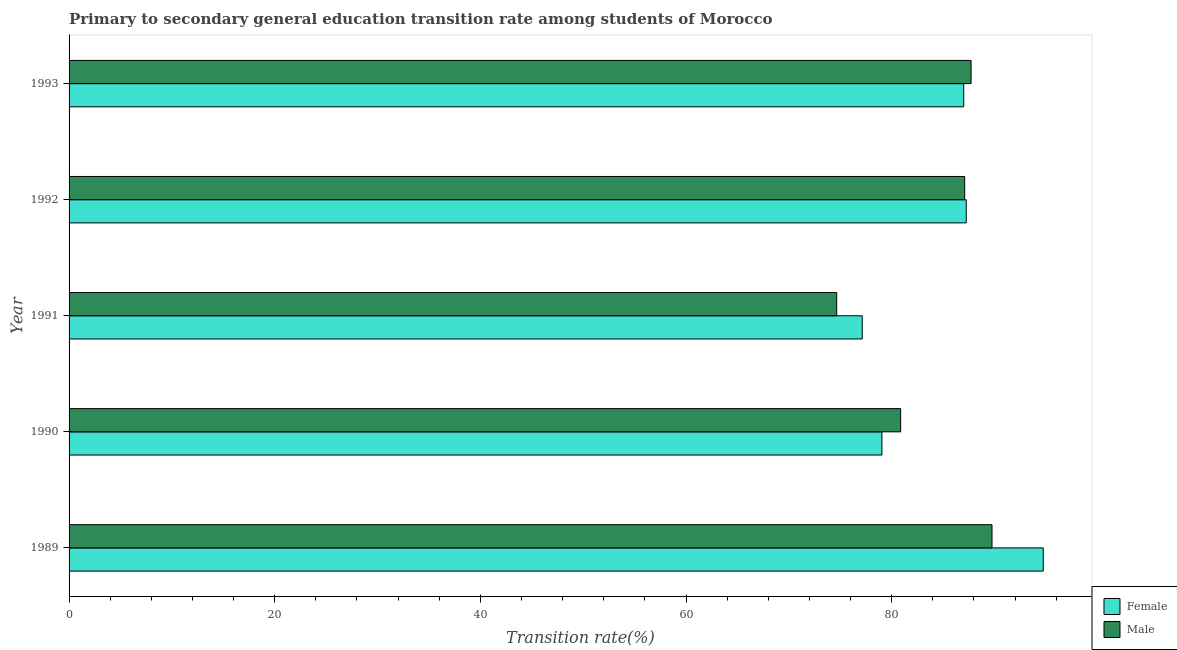What is the label of the 3rd group of bars from the top?
Offer a terse response. 1991. What is the transition rate among female students in 1989?
Offer a very short reply. 94.74. Across all years, what is the maximum transition rate among male students?
Keep it short and to the point. 89.76. Across all years, what is the minimum transition rate among male students?
Offer a very short reply. 74.65. In which year was the transition rate among male students maximum?
Your answer should be very brief. 1989. What is the total transition rate among male students in the graph?
Offer a very short reply. 420.11. What is the difference between the transition rate among male students in 1992 and that in 1993?
Your response must be concise. -0.62. What is the difference between the transition rate among female students in 1991 and the transition rate among male students in 1992?
Offer a very short reply. -9.96. What is the average transition rate among male students per year?
Make the answer very short. 84.02. In the year 1990, what is the difference between the transition rate among male students and transition rate among female students?
Keep it short and to the point. 1.82. What is the ratio of the transition rate among male students in 1989 to that in 1993?
Your response must be concise. 1.02. Is the difference between the transition rate among female students in 1991 and 1993 greater than the difference between the transition rate among male students in 1991 and 1993?
Give a very brief answer. Yes. What is the difference between the highest and the second highest transition rate among male students?
Offer a very short reply. 2.03. Is the sum of the transition rate among female students in 1991 and 1993 greater than the maximum transition rate among male students across all years?
Make the answer very short. Yes. How many bars are there?
Give a very brief answer. 10. Are all the bars in the graph horizontal?
Keep it short and to the point. Yes. Are the values on the major ticks of X-axis written in scientific E-notation?
Keep it short and to the point. No. Does the graph contain grids?
Your answer should be compact. No. How many legend labels are there?
Ensure brevity in your answer.  2. How are the legend labels stacked?
Your response must be concise. Vertical. What is the title of the graph?
Offer a very short reply. Primary to secondary general education transition rate among students of Morocco. Does "Male entrants" appear as one of the legend labels in the graph?
Your response must be concise. No. What is the label or title of the X-axis?
Offer a terse response. Transition rate(%). What is the Transition rate(%) in Female in 1989?
Provide a short and direct response. 94.74. What is the Transition rate(%) of Male in 1989?
Provide a short and direct response. 89.76. What is the Transition rate(%) of Female in 1990?
Provide a succinct answer. 79.05. What is the Transition rate(%) in Male in 1990?
Provide a short and direct response. 80.87. What is the Transition rate(%) in Female in 1991?
Give a very brief answer. 77.14. What is the Transition rate(%) in Male in 1991?
Offer a very short reply. 74.65. What is the Transition rate(%) of Female in 1992?
Your response must be concise. 87.25. What is the Transition rate(%) in Male in 1992?
Provide a short and direct response. 87.1. What is the Transition rate(%) of Female in 1993?
Offer a terse response. 87.01. What is the Transition rate(%) in Male in 1993?
Your answer should be very brief. 87.72. Across all years, what is the maximum Transition rate(%) of Female?
Provide a succinct answer. 94.74. Across all years, what is the maximum Transition rate(%) of Male?
Your response must be concise. 89.76. Across all years, what is the minimum Transition rate(%) in Female?
Make the answer very short. 77.14. Across all years, what is the minimum Transition rate(%) in Male?
Provide a succinct answer. 74.65. What is the total Transition rate(%) in Female in the graph?
Provide a succinct answer. 425.19. What is the total Transition rate(%) in Male in the graph?
Make the answer very short. 420.11. What is the difference between the Transition rate(%) of Female in 1989 and that in 1990?
Offer a very short reply. 15.69. What is the difference between the Transition rate(%) of Male in 1989 and that in 1990?
Give a very brief answer. 8.88. What is the difference between the Transition rate(%) of Female in 1989 and that in 1991?
Give a very brief answer. 17.61. What is the difference between the Transition rate(%) of Male in 1989 and that in 1991?
Provide a succinct answer. 15.1. What is the difference between the Transition rate(%) of Female in 1989 and that in 1992?
Keep it short and to the point. 7.49. What is the difference between the Transition rate(%) in Male in 1989 and that in 1992?
Your answer should be compact. 2.66. What is the difference between the Transition rate(%) of Female in 1989 and that in 1993?
Offer a very short reply. 7.74. What is the difference between the Transition rate(%) in Male in 1989 and that in 1993?
Provide a short and direct response. 2.03. What is the difference between the Transition rate(%) in Female in 1990 and that in 1991?
Keep it short and to the point. 1.92. What is the difference between the Transition rate(%) in Male in 1990 and that in 1991?
Provide a succinct answer. 6.22. What is the difference between the Transition rate(%) of Female in 1990 and that in 1992?
Ensure brevity in your answer.  -8.2. What is the difference between the Transition rate(%) in Male in 1990 and that in 1992?
Keep it short and to the point. -6.23. What is the difference between the Transition rate(%) of Female in 1990 and that in 1993?
Offer a very short reply. -7.95. What is the difference between the Transition rate(%) of Male in 1990 and that in 1993?
Provide a short and direct response. -6.85. What is the difference between the Transition rate(%) in Female in 1991 and that in 1992?
Ensure brevity in your answer.  -10.12. What is the difference between the Transition rate(%) of Male in 1991 and that in 1992?
Ensure brevity in your answer.  -12.45. What is the difference between the Transition rate(%) in Female in 1991 and that in 1993?
Your answer should be very brief. -9.87. What is the difference between the Transition rate(%) of Male in 1991 and that in 1993?
Offer a very short reply. -13.07. What is the difference between the Transition rate(%) in Female in 1992 and that in 1993?
Provide a short and direct response. 0.25. What is the difference between the Transition rate(%) in Male in 1992 and that in 1993?
Make the answer very short. -0.62. What is the difference between the Transition rate(%) in Female in 1989 and the Transition rate(%) in Male in 1990?
Your answer should be compact. 13.87. What is the difference between the Transition rate(%) of Female in 1989 and the Transition rate(%) of Male in 1991?
Provide a short and direct response. 20.09. What is the difference between the Transition rate(%) in Female in 1989 and the Transition rate(%) in Male in 1992?
Provide a short and direct response. 7.64. What is the difference between the Transition rate(%) of Female in 1989 and the Transition rate(%) of Male in 1993?
Offer a terse response. 7.02. What is the difference between the Transition rate(%) in Female in 1990 and the Transition rate(%) in Male in 1991?
Offer a very short reply. 4.4. What is the difference between the Transition rate(%) of Female in 1990 and the Transition rate(%) of Male in 1992?
Provide a short and direct response. -8.05. What is the difference between the Transition rate(%) of Female in 1990 and the Transition rate(%) of Male in 1993?
Offer a very short reply. -8.67. What is the difference between the Transition rate(%) in Female in 1991 and the Transition rate(%) in Male in 1992?
Give a very brief answer. -9.96. What is the difference between the Transition rate(%) of Female in 1991 and the Transition rate(%) of Male in 1993?
Your answer should be very brief. -10.59. What is the difference between the Transition rate(%) in Female in 1992 and the Transition rate(%) in Male in 1993?
Make the answer very short. -0.47. What is the average Transition rate(%) of Female per year?
Ensure brevity in your answer.  85.04. What is the average Transition rate(%) of Male per year?
Your response must be concise. 84.02. In the year 1989, what is the difference between the Transition rate(%) of Female and Transition rate(%) of Male?
Your answer should be compact. 4.99. In the year 1990, what is the difference between the Transition rate(%) of Female and Transition rate(%) of Male?
Provide a succinct answer. -1.82. In the year 1991, what is the difference between the Transition rate(%) of Female and Transition rate(%) of Male?
Offer a very short reply. 2.48. In the year 1992, what is the difference between the Transition rate(%) of Female and Transition rate(%) of Male?
Make the answer very short. 0.15. In the year 1993, what is the difference between the Transition rate(%) in Female and Transition rate(%) in Male?
Keep it short and to the point. -0.72. What is the ratio of the Transition rate(%) in Female in 1989 to that in 1990?
Your answer should be compact. 1.2. What is the ratio of the Transition rate(%) in Male in 1989 to that in 1990?
Your answer should be very brief. 1.11. What is the ratio of the Transition rate(%) in Female in 1989 to that in 1991?
Give a very brief answer. 1.23. What is the ratio of the Transition rate(%) of Male in 1989 to that in 1991?
Offer a terse response. 1.2. What is the ratio of the Transition rate(%) in Female in 1989 to that in 1992?
Your response must be concise. 1.09. What is the ratio of the Transition rate(%) in Male in 1989 to that in 1992?
Provide a short and direct response. 1.03. What is the ratio of the Transition rate(%) in Female in 1989 to that in 1993?
Your response must be concise. 1.09. What is the ratio of the Transition rate(%) of Male in 1989 to that in 1993?
Provide a succinct answer. 1.02. What is the ratio of the Transition rate(%) of Female in 1990 to that in 1991?
Offer a very short reply. 1.02. What is the ratio of the Transition rate(%) in Male in 1990 to that in 1991?
Keep it short and to the point. 1.08. What is the ratio of the Transition rate(%) in Female in 1990 to that in 1992?
Your answer should be compact. 0.91. What is the ratio of the Transition rate(%) of Male in 1990 to that in 1992?
Provide a short and direct response. 0.93. What is the ratio of the Transition rate(%) in Female in 1990 to that in 1993?
Offer a very short reply. 0.91. What is the ratio of the Transition rate(%) in Male in 1990 to that in 1993?
Your response must be concise. 0.92. What is the ratio of the Transition rate(%) of Female in 1991 to that in 1992?
Keep it short and to the point. 0.88. What is the ratio of the Transition rate(%) of Female in 1991 to that in 1993?
Provide a succinct answer. 0.89. What is the ratio of the Transition rate(%) of Male in 1991 to that in 1993?
Your response must be concise. 0.85. What is the ratio of the Transition rate(%) in Female in 1992 to that in 1993?
Make the answer very short. 1. What is the ratio of the Transition rate(%) of Male in 1992 to that in 1993?
Make the answer very short. 0.99. What is the difference between the highest and the second highest Transition rate(%) in Female?
Provide a succinct answer. 7.49. What is the difference between the highest and the second highest Transition rate(%) in Male?
Offer a terse response. 2.03. What is the difference between the highest and the lowest Transition rate(%) in Female?
Your answer should be very brief. 17.61. What is the difference between the highest and the lowest Transition rate(%) in Male?
Your response must be concise. 15.1. 